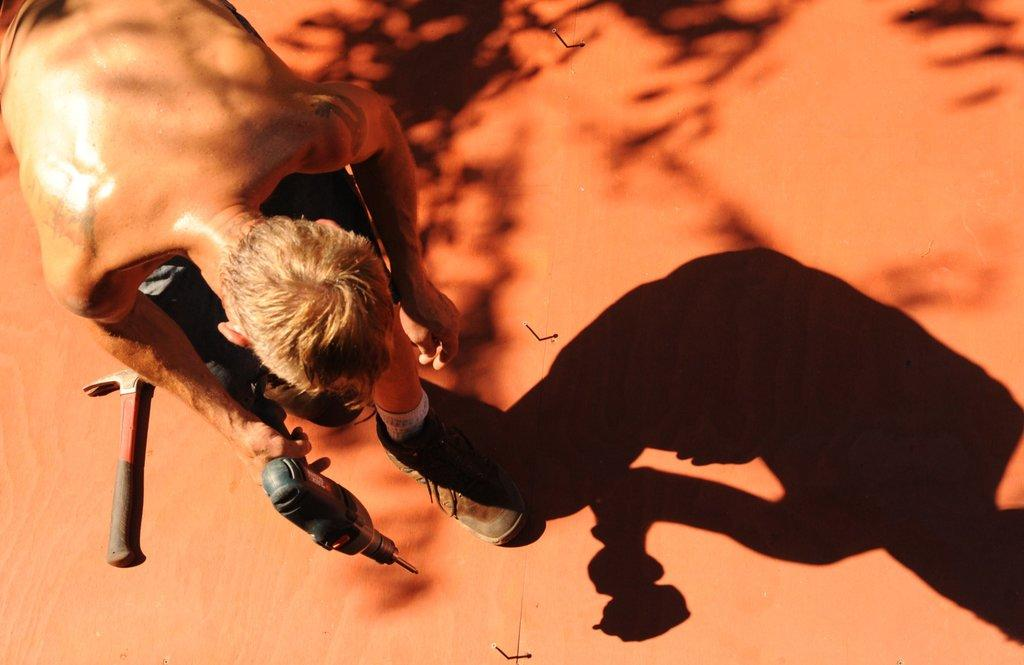What can be seen in the image? There is a person in the image. What is the person doing in the image? The person is holding an object. Can you describe any other visual elements in the image? There is a shadow of the person in the image, and there is another object placed on the floor. What type of kettle is being used to power the engine in the image? There is no kettle or engine present in the image. What is being served for dinner in the image? The image does not depict any dinner or food being served. 